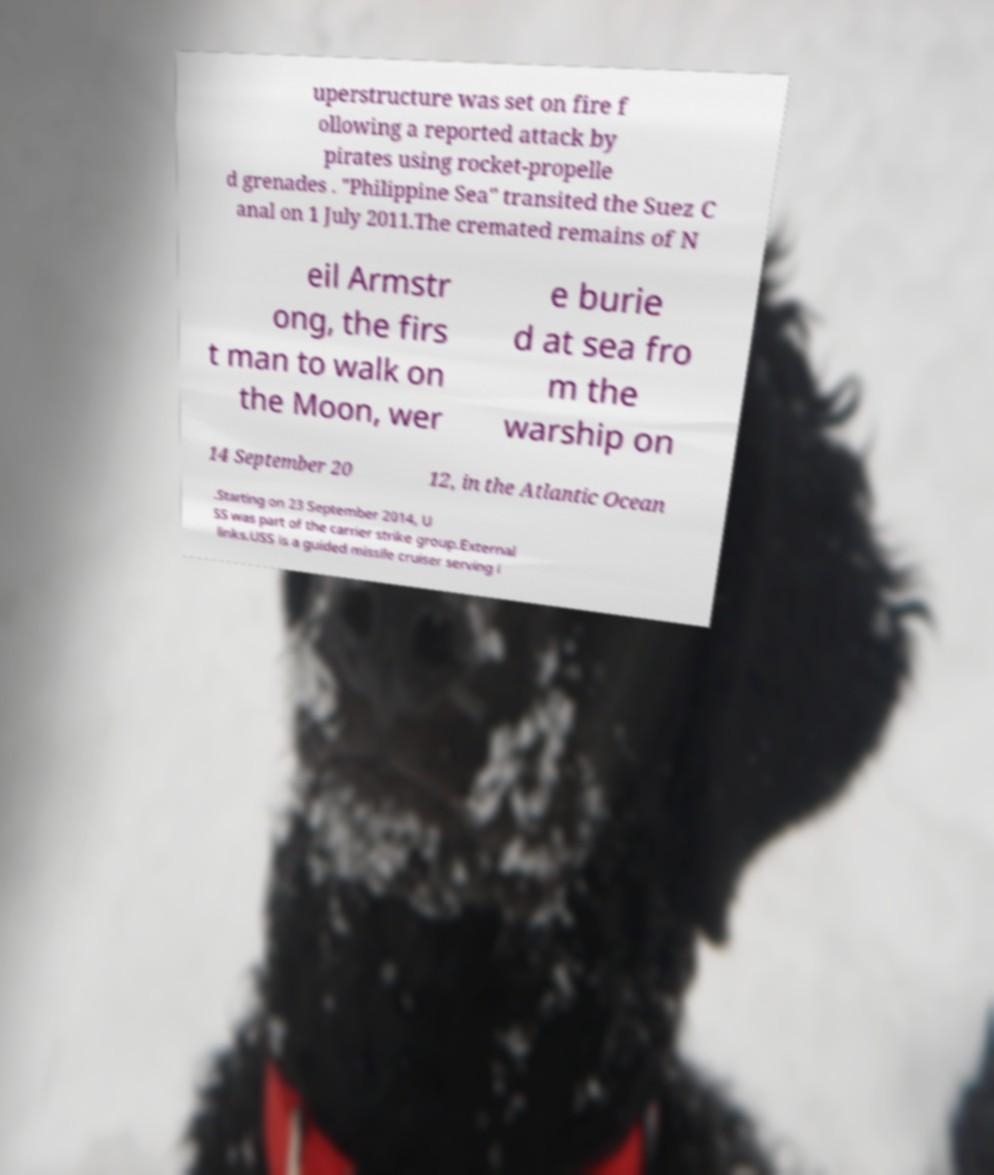Please identify and transcribe the text found in this image. uperstructure was set on fire f ollowing a reported attack by pirates using rocket-propelle d grenades . "Philippine Sea" transited the Suez C anal on 1 July 2011.The cremated remains of N eil Armstr ong, the firs t man to walk on the Moon, wer e burie d at sea fro m the warship on 14 September 20 12, in the Atlantic Ocean .Starting on 23 September 2014, U SS was part of the carrier strike group.External links.USS is a guided missile cruiser serving i 